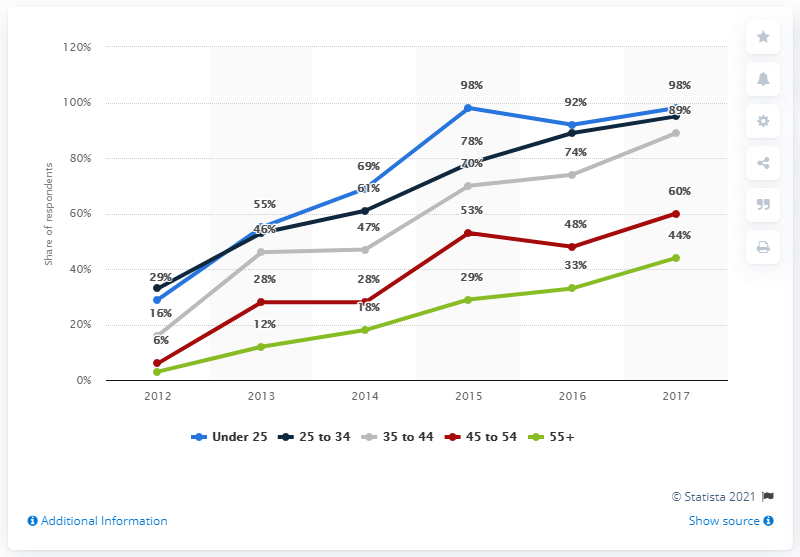Specify some key components in this picture. The average for the year 2015 was 65.6. The age group with the highest point on the graph is under 25. In 2017, it was estimated that 98% of smartphone users in Poland were under the age of 25. In 2017, the smartphone penetration level for users 55 years of age and older in Poland was 44%. 